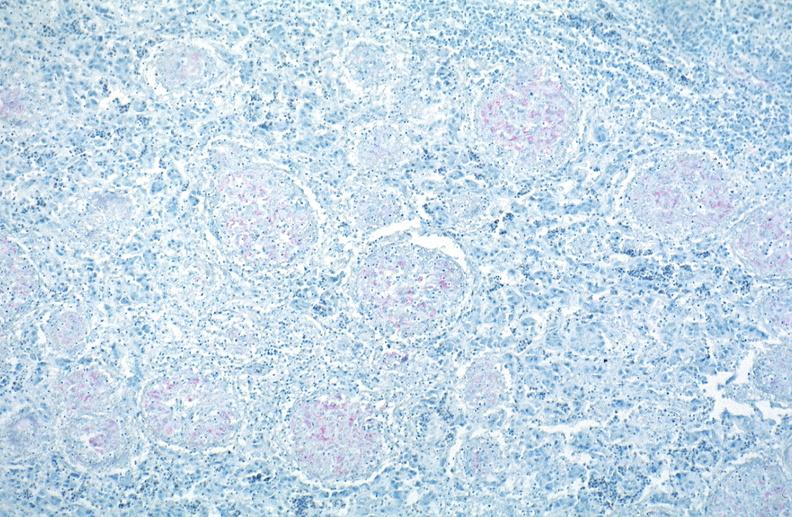what does this image show?
Answer the question using a single word or phrase. Lung 